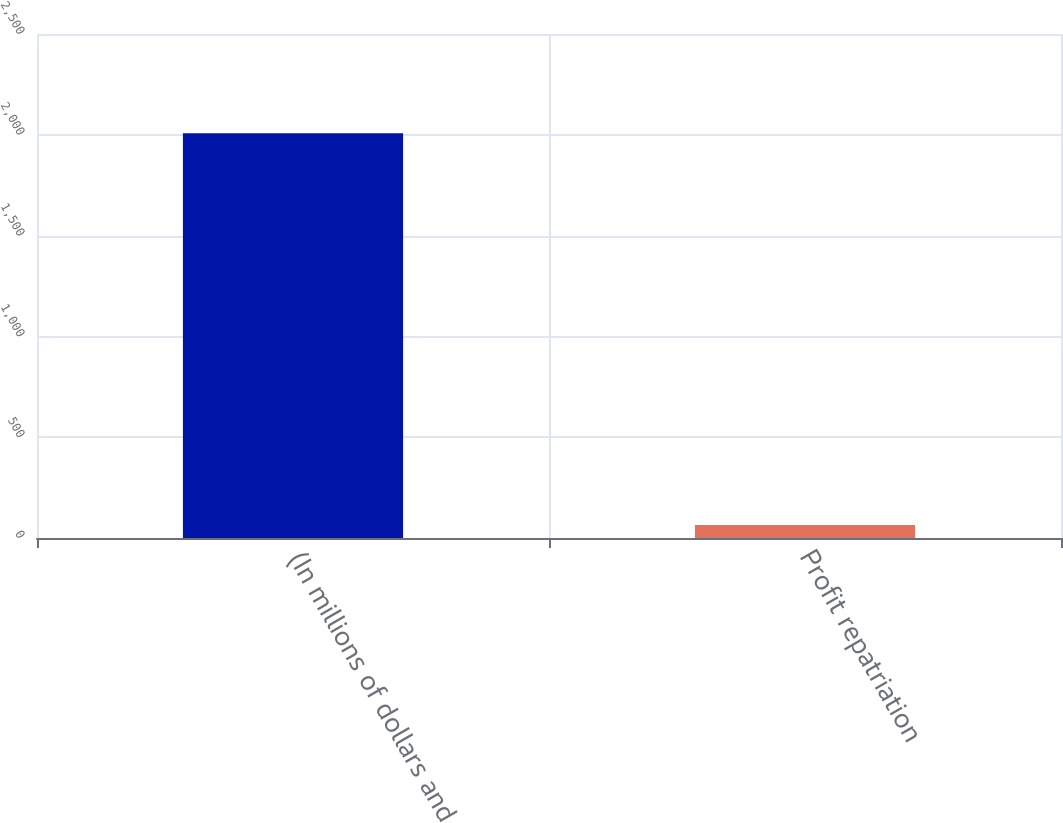<chart> <loc_0><loc_0><loc_500><loc_500><bar_chart><fcel>(In millions of dollars and<fcel>Profit repatriation<nl><fcel>2008<fcel>64.1<nl></chart> 